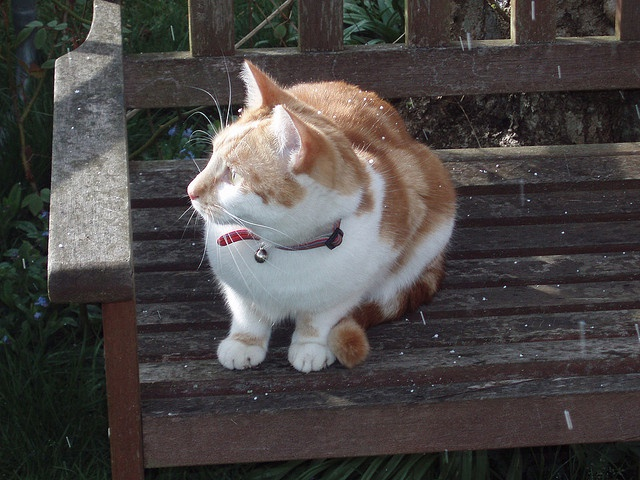Describe the objects in this image and their specific colors. I can see bench in black, gray, and darkgray tones and cat in black, darkgray, gray, and lightgray tones in this image. 